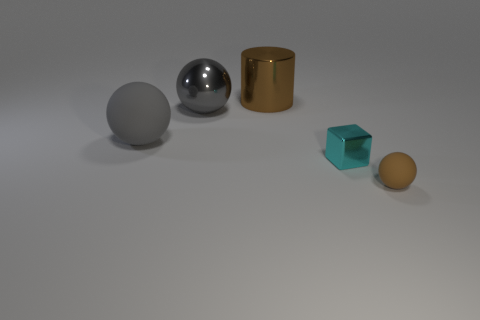Add 5 big gray metal things. How many objects exist? 10 Subtract all cubes. How many objects are left? 4 Subtract 0 yellow cylinders. How many objects are left? 5 Subtract all small brown matte things. Subtract all tiny cyan things. How many objects are left? 3 Add 3 big balls. How many big balls are left? 5 Add 2 big gray rubber objects. How many big gray rubber objects exist? 3 